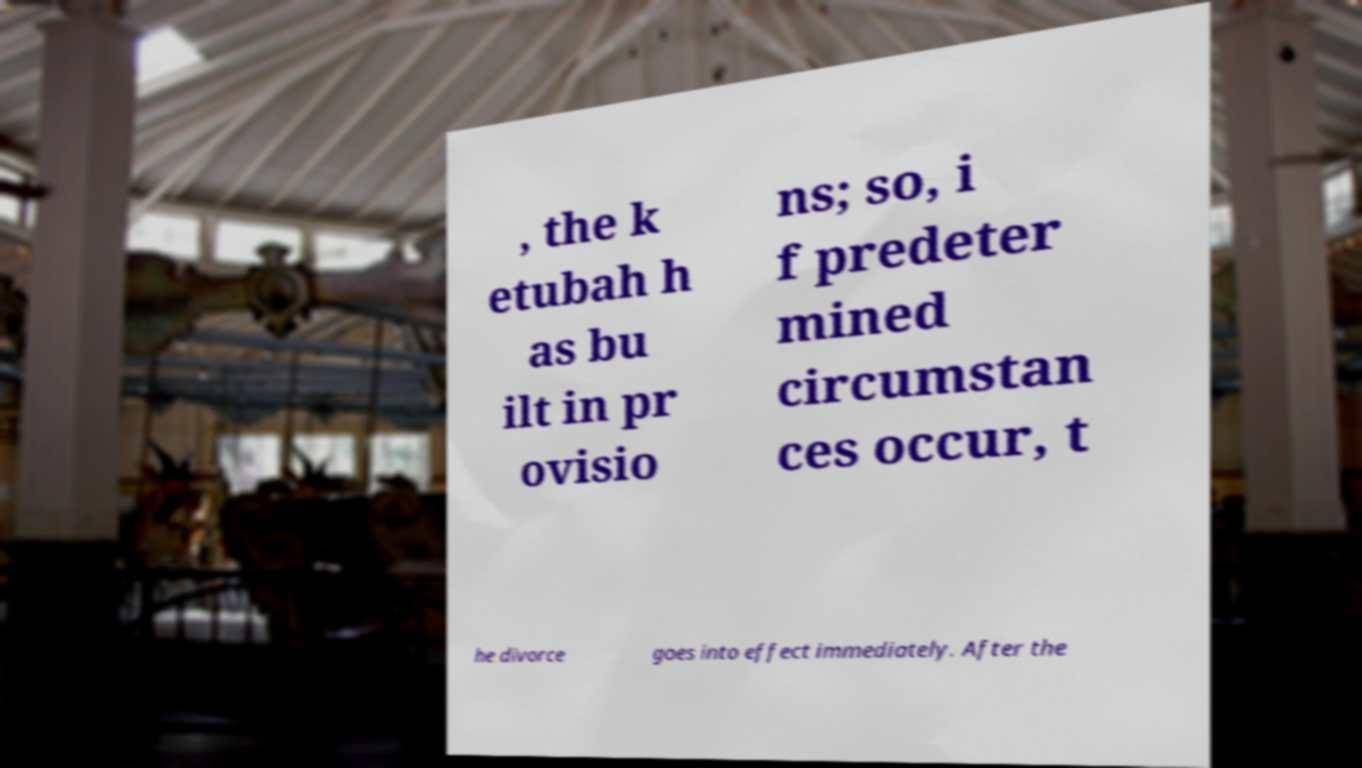What messages or text are displayed in this image? I need them in a readable, typed format. , the k etubah h as bu ilt in pr ovisio ns; so, i f predeter mined circumstan ces occur, t he divorce goes into effect immediately. After the 